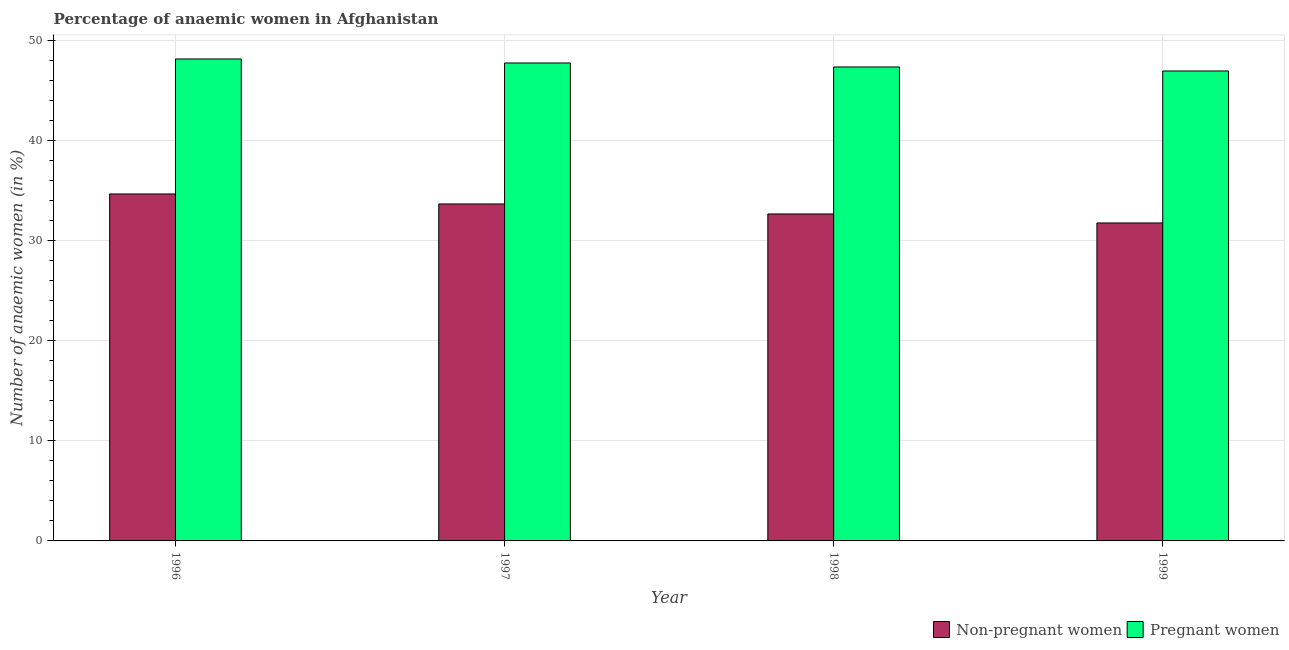How many groups of bars are there?
Your response must be concise. 4. Are the number of bars per tick equal to the number of legend labels?
Provide a succinct answer. Yes. Are the number of bars on each tick of the X-axis equal?
Your answer should be compact. Yes. How many bars are there on the 3rd tick from the left?
Make the answer very short. 2. In how many cases, is the number of bars for a given year not equal to the number of legend labels?
Your answer should be very brief. 0. What is the percentage of pregnant anaemic women in 1996?
Your response must be concise. 48.2. Across all years, what is the maximum percentage of pregnant anaemic women?
Offer a terse response. 48.2. In which year was the percentage of pregnant anaemic women minimum?
Provide a succinct answer. 1999. What is the total percentage of pregnant anaemic women in the graph?
Offer a very short reply. 190.4. What is the difference between the percentage of pregnant anaemic women in 1997 and that in 1999?
Make the answer very short. 0.8. What is the difference between the percentage of non-pregnant anaemic women in 1997 and the percentage of pregnant anaemic women in 1998?
Offer a terse response. 1. What is the average percentage of non-pregnant anaemic women per year?
Provide a short and direct response. 33.23. In the year 1996, what is the difference between the percentage of non-pregnant anaemic women and percentage of pregnant anaemic women?
Offer a terse response. 0. What is the ratio of the percentage of pregnant anaemic women in 1996 to that in 1999?
Give a very brief answer. 1.03. Is the percentage of pregnant anaemic women in 1998 less than that in 1999?
Ensure brevity in your answer.  No. What is the difference between the highest and the second highest percentage of non-pregnant anaemic women?
Your response must be concise. 1. What is the difference between the highest and the lowest percentage of pregnant anaemic women?
Keep it short and to the point. 1.2. In how many years, is the percentage of non-pregnant anaemic women greater than the average percentage of non-pregnant anaemic women taken over all years?
Provide a succinct answer. 2. What does the 2nd bar from the left in 1996 represents?
Ensure brevity in your answer.  Pregnant women. What does the 1st bar from the right in 1998 represents?
Provide a succinct answer. Pregnant women. Are all the bars in the graph horizontal?
Make the answer very short. No. Are the values on the major ticks of Y-axis written in scientific E-notation?
Make the answer very short. No. Does the graph contain any zero values?
Offer a terse response. No. Where does the legend appear in the graph?
Provide a short and direct response. Bottom right. What is the title of the graph?
Make the answer very short. Percentage of anaemic women in Afghanistan. What is the label or title of the X-axis?
Provide a succinct answer. Year. What is the label or title of the Y-axis?
Make the answer very short. Number of anaemic women (in %). What is the Number of anaemic women (in %) of Non-pregnant women in 1996?
Provide a succinct answer. 34.7. What is the Number of anaemic women (in %) of Pregnant women in 1996?
Offer a terse response. 48.2. What is the Number of anaemic women (in %) in Non-pregnant women in 1997?
Your response must be concise. 33.7. What is the Number of anaemic women (in %) of Pregnant women in 1997?
Provide a short and direct response. 47.8. What is the Number of anaemic women (in %) in Non-pregnant women in 1998?
Your response must be concise. 32.7. What is the Number of anaemic women (in %) of Pregnant women in 1998?
Offer a terse response. 47.4. What is the Number of anaemic women (in %) of Non-pregnant women in 1999?
Your response must be concise. 31.8. Across all years, what is the maximum Number of anaemic women (in %) of Non-pregnant women?
Offer a terse response. 34.7. Across all years, what is the maximum Number of anaemic women (in %) in Pregnant women?
Ensure brevity in your answer.  48.2. Across all years, what is the minimum Number of anaemic women (in %) in Non-pregnant women?
Make the answer very short. 31.8. Across all years, what is the minimum Number of anaemic women (in %) in Pregnant women?
Provide a succinct answer. 47. What is the total Number of anaemic women (in %) of Non-pregnant women in the graph?
Offer a very short reply. 132.9. What is the total Number of anaemic women (in %) of Pregnant women in the graph?
Keep it short and to the point. 190.4. What is the difference between the Number of anaemic women (in %) of Non-pregnant women in 1996 and that in 1998?
Keep it short and to the point. 2. What is the difference between the Number of anaemic women (in %) in Pregnant women in 1996 and that in 1998?
Offer a terse response. 0.8. What is the difference between the Number of anaemic women (in %) of Non-pregnant women in 1996 and that in 1999?
Your answer should be very brief. 2.9. What is the difference between the Number of anaemic women (in %) of Pregnant women in 1996 and that in 1999?
Keep it short and to the point. 1.2. What is the difference between the Number of anaemic women (in %) of Pregnant women in 1997 and that in 1998?
Your response must be concise. 0.4. What is the difference between the Number of anaemic women (in %) in Non-pregnant women in 1997 and that in 1999?
Offer a terse response. 1.9. What is the difference between the Number of anaemic women (in %) in Non-pregnant women in 1998 and that in 1999?
Your answer should be very brief. 0.9. What is the difference between the Number of anaemic women (in %) of Pregnant women in 1998 and that in 1999?
Give a very brief answer. 0.4. What is the difference between the Number of anaemic women (in %) of Non-pregnant women in 1996 and the Number of anaemic women (in %) of Pregnant women in 1997?
Keep it short and to the point. -13.1. What is the difference between the Number of anaemic women (in %) in Non-pregnant women in 1996 and the Number of anaemic women (in %) in Pregnant women in 1999?
Ensure brevity in your answer.  -12.3. What is the difference between the Number of anaemic women (in %) in Non-pregnant women in 1997 and the Number of anaemic women (in %) in Pregnant women in 1998?
Provide a short and direct response. -13.7. What is the difference between the Number of anaemic women (in %) in Non-pregnant women in 1997 and the Number of anaemic women (in %) in Pregnant women in 1999?
Provide a succinct answer. -13.3. What is the difference between the Number of anaemic women (in %) in Non-pregnant women in 1998 and the Number of anaemic women (in %) in Pregnant women in 1999?
Your response must be concise. -14.3. What is the average Number of anaemic women (in %) in Non-pregnant women per year?
Keep it short and to the point. 33.23. What is the average Number of anaemic women (in %) of Pregnant women per year?
Provide a short and direct response. 47.6. In the year 1996, what is the difference between the Number of anaemic women (in %) in Non-pregnant women and Number of anaemic women (in %) in Pregnant women?
Your answer should be compact. -13.5. In the year 1997, what is the difference between the Number of anaemic women (in %) in Non-pregnant women and Number of anaemic women (in %) in Pregnant women?
Offer a terse response. -14.1. In the year 1998, what is the difference between the Number of anaemic women (in %) in Non-pregnant women and Number of anaemic women (in %) in Pregnant women?
Provide a short and direct response. -14.7. In the year 1999, what is the difference between the Number of anaemic women (in %) in Non-pregnant women and Number of anaemic women (in %) in Pregnant women?
Offer a very short reply. -15.2. What is the ratio of the Number of anaemic women (in %) in Non-pregnant women in 1996 to that in 1997?
Ensure brevity in your answer.  1.03. What is the ratio of the Number of anaemic women (in %) in Pregnant women in 1996 to that in 1997?
Your answer should be very brief. 1.01. What is the ratio of the Number of anaemic women (in %) of Non-pregnant women in 1996 to that in 1998?
Provide a short and direct response. 1.06. What is the ratio of the Number of anaemic women (in %) of Pregnant women in 1996 to that in 1998?
Offer a terse response. 1.02. What is the ratio of the Number of anaemic women (in %) of Non-pregnant women in 1996 to that in 1999?
Provide a short and direct response. 1.09. What is the ratio of the Number of anaemic women (in %) in Pregnant women in 1996 to that in 1999?
Ensure brevity in your answer.  1.03. What is the ratio of the Number of anaemic women (in %) of Non-pregnant women in 1997 to that in 1998?
Ensure brevity in your answer.  1.03. What is the ratio of the Number of anaemic women (in %) in Pregnant women in 1997 to that in 1998?
Provide a succinct answer. 1.01. What is the ratio of the Number of anaemic women (in %) of Non-pregnant women in 1997 to that in 1999?
Your answer should be very brief. 1.06. What is the ratio of the Number of anaemic women (in %) in Non-pregnant women in 1998 to that in 1999?
Your response must be concise. 1.03. What is the ratio of the Number of anaemic women (in %) of Pregnant women in 1998 to that in 1999?
Your response must be concise. 1.01. What is the difference between the highest and the second highest Number of anaemic women (in %) in Non-pregnant women?
Ensure brevity in your answer.  1. What is the difference between the highest and the lowest Number of anaemic women (in %) in Pregnant women?
Offer a terse response. 1.2. 